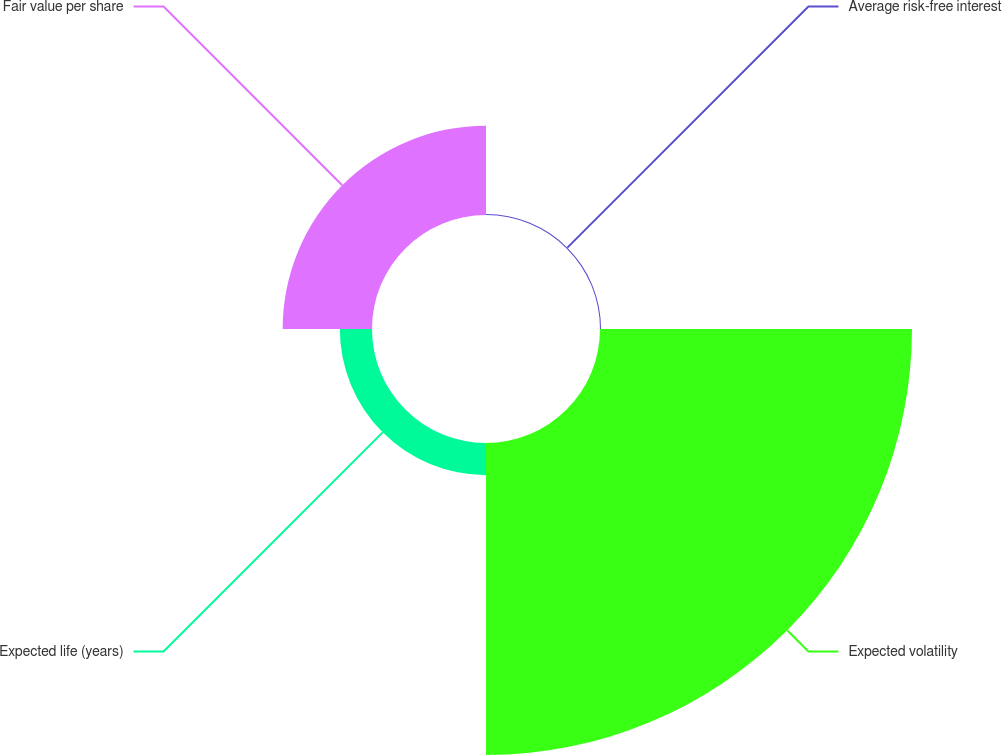Convert chart to OTSL. <chart><loc_0><loc_0><loc_500><loc_500><pie_chart><fcel>Average risk-free interest<fcel>Expected volatility<fcel>Expected life (years)<fcel>Fair value per share<nl><fcel>0.24%<fcel>71.8%<fcel>7.4%<fcel>20.56%<nl></chart> 